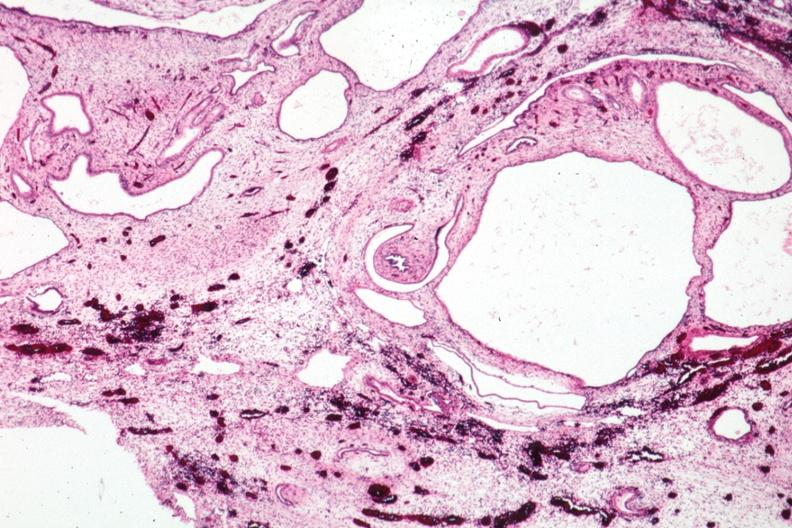what is present?
Answer the question using a single word or phrase. Kidney 